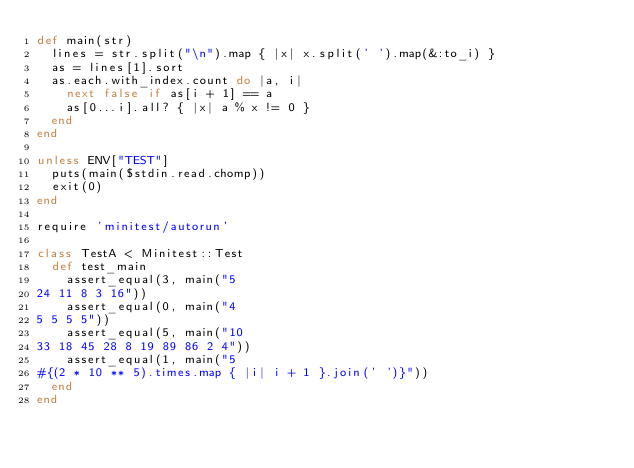Convert code to text. <code><loc_0><loc_0><loc_500><loc_500><_Ruby_>def main(str)
  lines = str.split("\n").map { |x| x.split(' ').map(&:to_i) }
  as = lines[1].sort
  as.each.with_index.count do |a, i|
    next false if as[i + 1] == a
    as[0...i].all? { |x| a % x != 0 }
  end
end

unless ENV["TEST"]
  puts(main($stdin.read.chomp))
  exit(0)
end

require 'minitest/autorun'

class TestA < Minitest::Test
  def test_main
    assert_equal(3, main("5
24 11 8 3 16"))
    assert_equal(0, main("4
5 5 5 5"))
    assert_equal(5, main("10
33 18 45 28 8 19 89 86 2 4"))
    assert_equal(1, main("5
#{(2 * 10 ** 5).times.map { |i| i + 1 }.join(' ')}"))
  end
end


</code> 